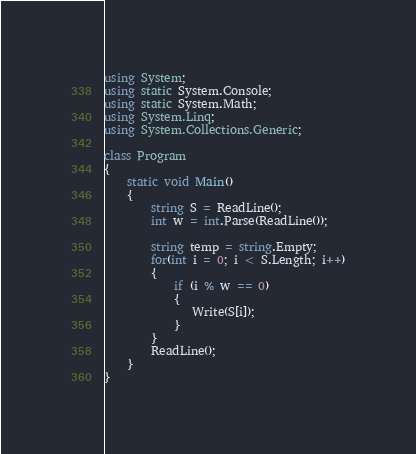Convert code to text. <code><loc_0><loc_0><loc_500><loc_500><_C#_>using System;
using static System.Console;
using static System.Math;
using System.Linq;
using System.Collections.Generic;

class Program
{
    static void Main()
    {
        string S = ReadLine();
        int w = int.Parse(ReadLine());

        string temp = string.Empty;
        for(int i = 0; i < S.Length; i++)
        {
            if (i % w == 0)
            {
               Write(S[i]);
            }
        }
        ReadLine();
    }
}</code> 